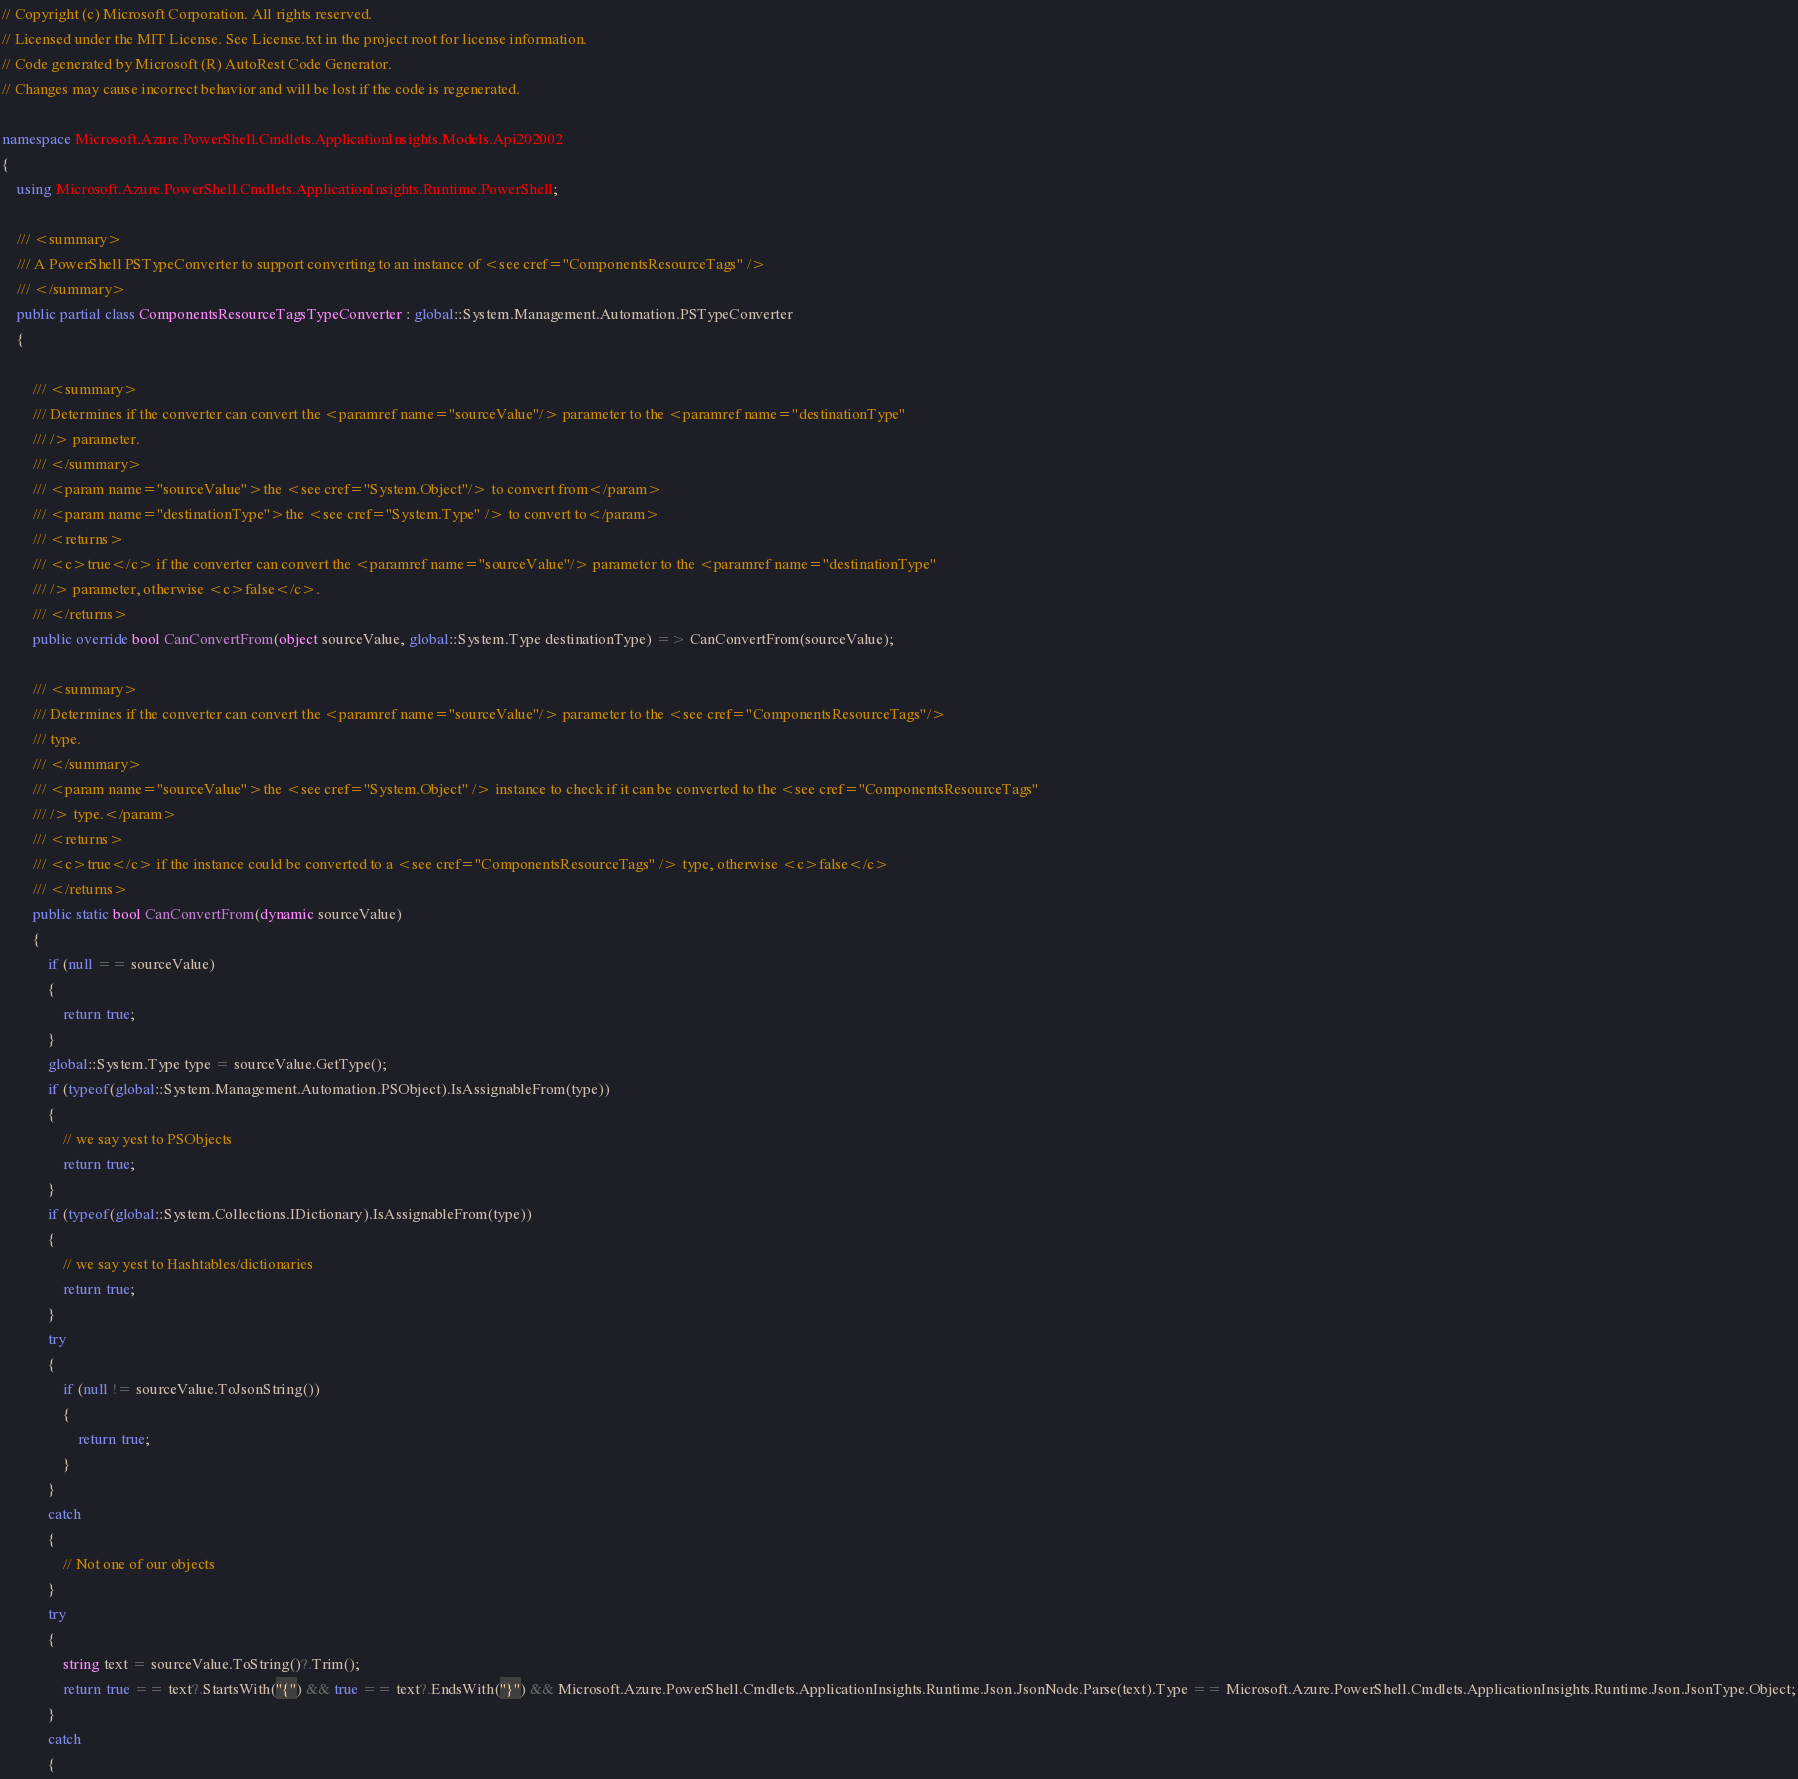<code> <loc_0><loc_0><loc_500><loc_500><_C#_>// Copyright (c) Microsoft Corporation. All rights reserved.
// Licensed under the MIT License. See License.txt in the project root for license information.
// Code generated by Microsoft (R) AutoRest Code Generator.
// Changes may cause incorrect behavior and will be lost if the code is regenerated.

namespace Microsoft.Azure.PowerShell.Cmdlets.ApplicationInsights.Models.Api202002
{
    using Microsoft.Azure.PowerShell.Cmdlets.ApplicationInsights.Runtime.PowerShell;

    /// <summary>
    /// A PowerShell PSTypeConverter to support converting to an instance of <see cref="ComponentsResourceTags" />
    /// </summary>
    public partial class ComponentsResourceTagsTypeConverter : global::System.Management.Automation.PSTypeConverter
    {

        /// <summary>
        /// Determines if the converter can convert the <paramref name="sourceValue"/> parameter to the <paramref name="destinationType"
        /// /> parameter.
        /// </summary>
        /// <param name="sourceValue">the <see cref="System.Object"/> to convert from</param>
        /// <param name="destinationType">the <see cref="System.Type" /> to convert to</param>
        /// <returns>
        /// <c>true</c> if the converter can convert the <paramref name="sourceValue"/> parameter to the <paramref name="destinationType"
        /// /> parameter, otherwise <c>false</c>.
        /// </returns>
        public override bool CanConvertFrom(object sourceValue, global::System.Type destinationType) => CanConvertFrom(sourceValue);

        /// <summary>
        /// Determines if the converter can convert the <paramref name="sourceValue"/> parameter to the <see cref="ComponentsResourceTags"/>
        /// type.
        /// </summary>
        /// <param name="sourceValue">the <see cref="System.Object" /> instance to check if it can be converted to the <see cref="ComponentsResourceTags"
        /// /> type.</param>
        /// <returns>
        /// <c>true</c> if the instance could be converted to a <see cref="ComponentsResourceTags" /> type, otherwise <c>false</c>
        /// </returns>
        public static bool CanConvertFrom(dynamic sourceValue)
        {
            if (null == sourceValue)
            {
                return true;
            }
            global::System.Type type = sourceValue.GetType();
            if (typeof(global::System.Management.Automation.PSObject).IsAssignableFrom(type))
            {
                // we say yest to PSObjects
                return true;
            }
            if (typeof(global::System.Collections.IDictionary).IsAssignableFrom(type))
            {
                // we say yest to Hashtables/dictionaries
                return true;
            }
            try
            {
                if (null != sourceValue.ToJsonString())
                {
                    return true;
                }
            }
            catch
            {
                // Not one of our objects
            }
            try
            {
                string text = sourceValue.ToString()?.Trim();
                return true == text?.StartsWith("{") && true == text?.EndsWith("}") && Microsoft.Azure.PowerShell.Cmdlets.ApplicationInsights.Runtime.Json.JsonNode.Parse(text).Type == Microsoft.Azure.PowerShell.Cmdlets.ApplicationInsights.Runtime.Json.JsonType.Object;
            }
            catch
            {</code> 